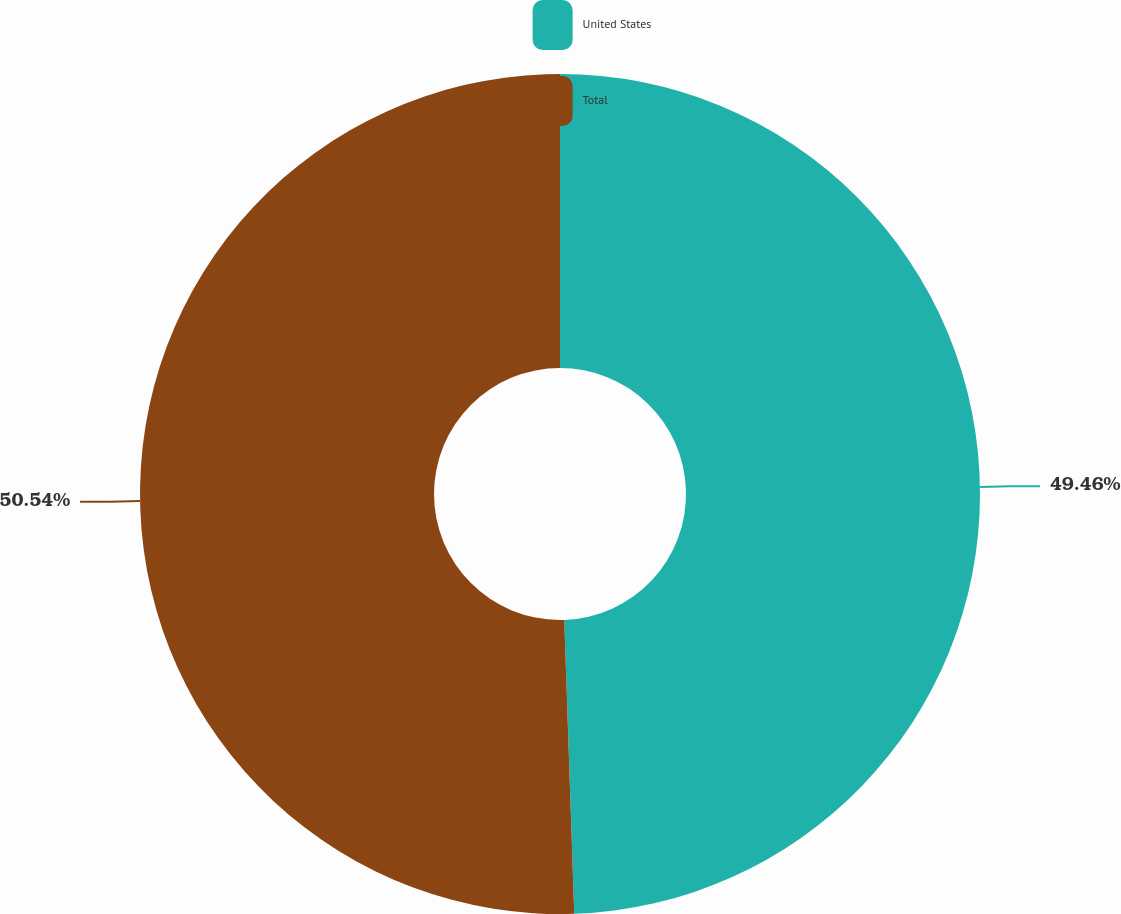Convert chart to OTSL. <chart><loc_0><loc_0><loc_500><loc_500><pie_chart><fcel>United States<fcel>Total<nl><fcel>49.46%<fcel>50.54%<nl></chart> 